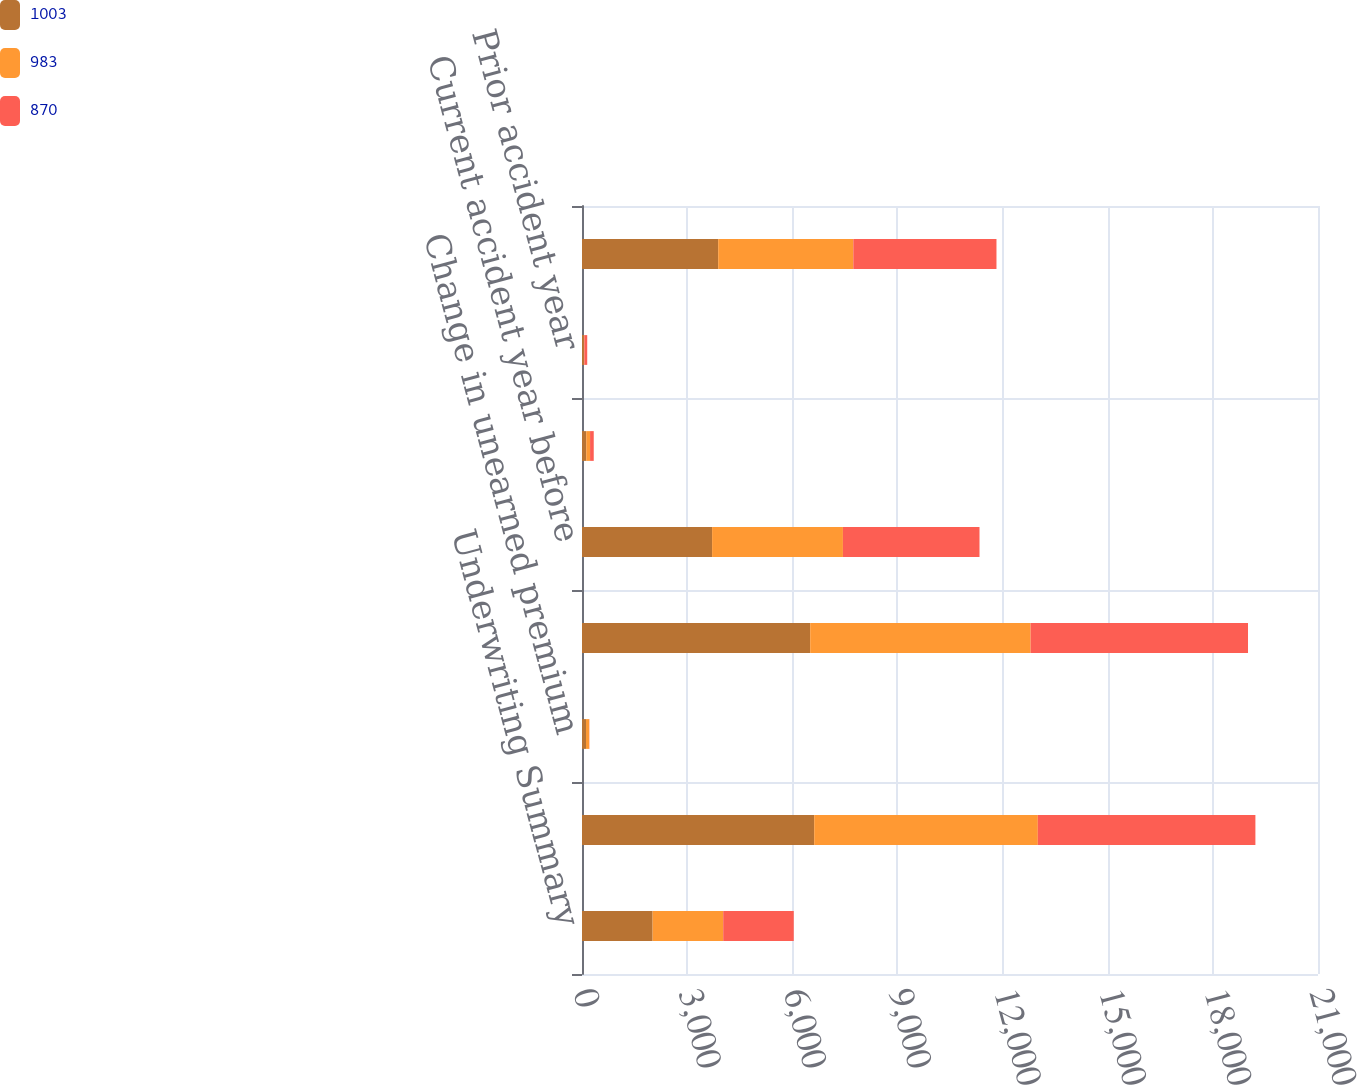Convert chart. <chart><loc_0><loc_0><loc_500><loc_500><stacked_bar_chart><ecel><fcel>Underwriting Summary<fcel>Written premiums<fcel>Change in unearned premium<fcel>Earned premiums<fcel>Current accident year before<fcel>Current accident year<fcel>Prior accident year<fcel>Total losses and loss<nl><fcel>1003<fcel>2015<fcel>6625<fcel>114<fcel>6511<fcel>3712<fcel>121<fcel>53<fcel>3886<nl><fcel>983<fcel>2014<fcel>6381<fcel>92<fcel>6289<fcel>3733<fcel>109<fcel>13<fcel>3855<nl><fcel>870<fcel>2013<fcel>6208<fcel>5<fcel>6203<fcel>3897<fcel>105<fcel>83<fcel>4085<nl></chart> 